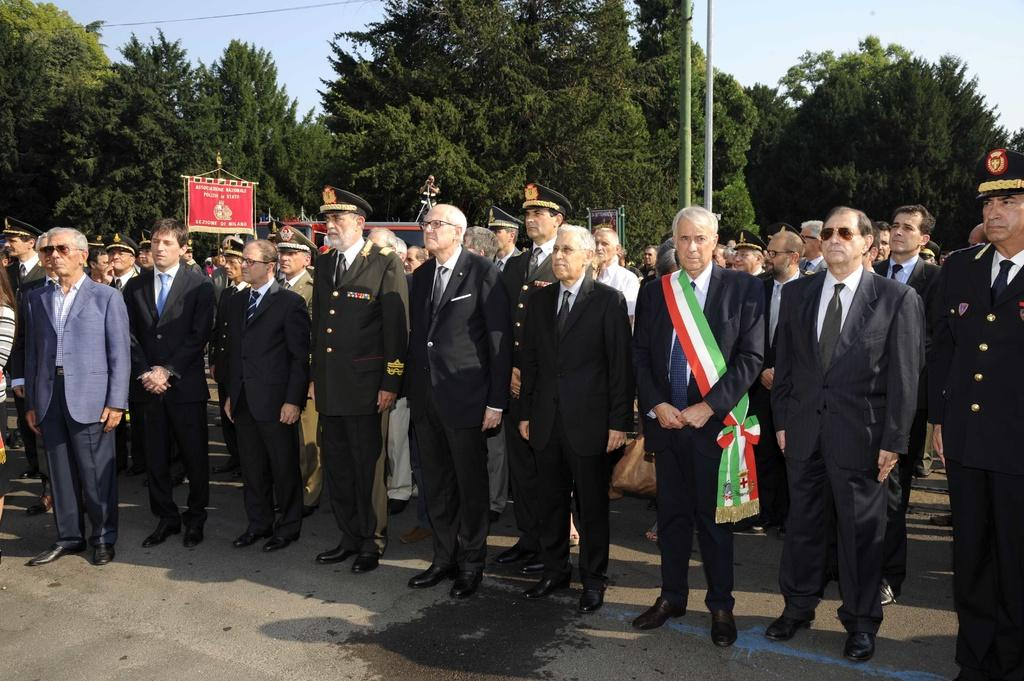What are the persons in the image wearing? The persons in the image are wearing suits. What are the persons doing in the image? The persons are standing. What can be seen in the background of the image? There are two poles and trees in the background of the image. How many lights can be seen hanging from the poles in the image? There is no mention of lights in the image; only two poles and trees are present in the background. What type of lizards are crawling on the persons in the image? There are no lizards present in the image; the persons are wearing suits and standing. 